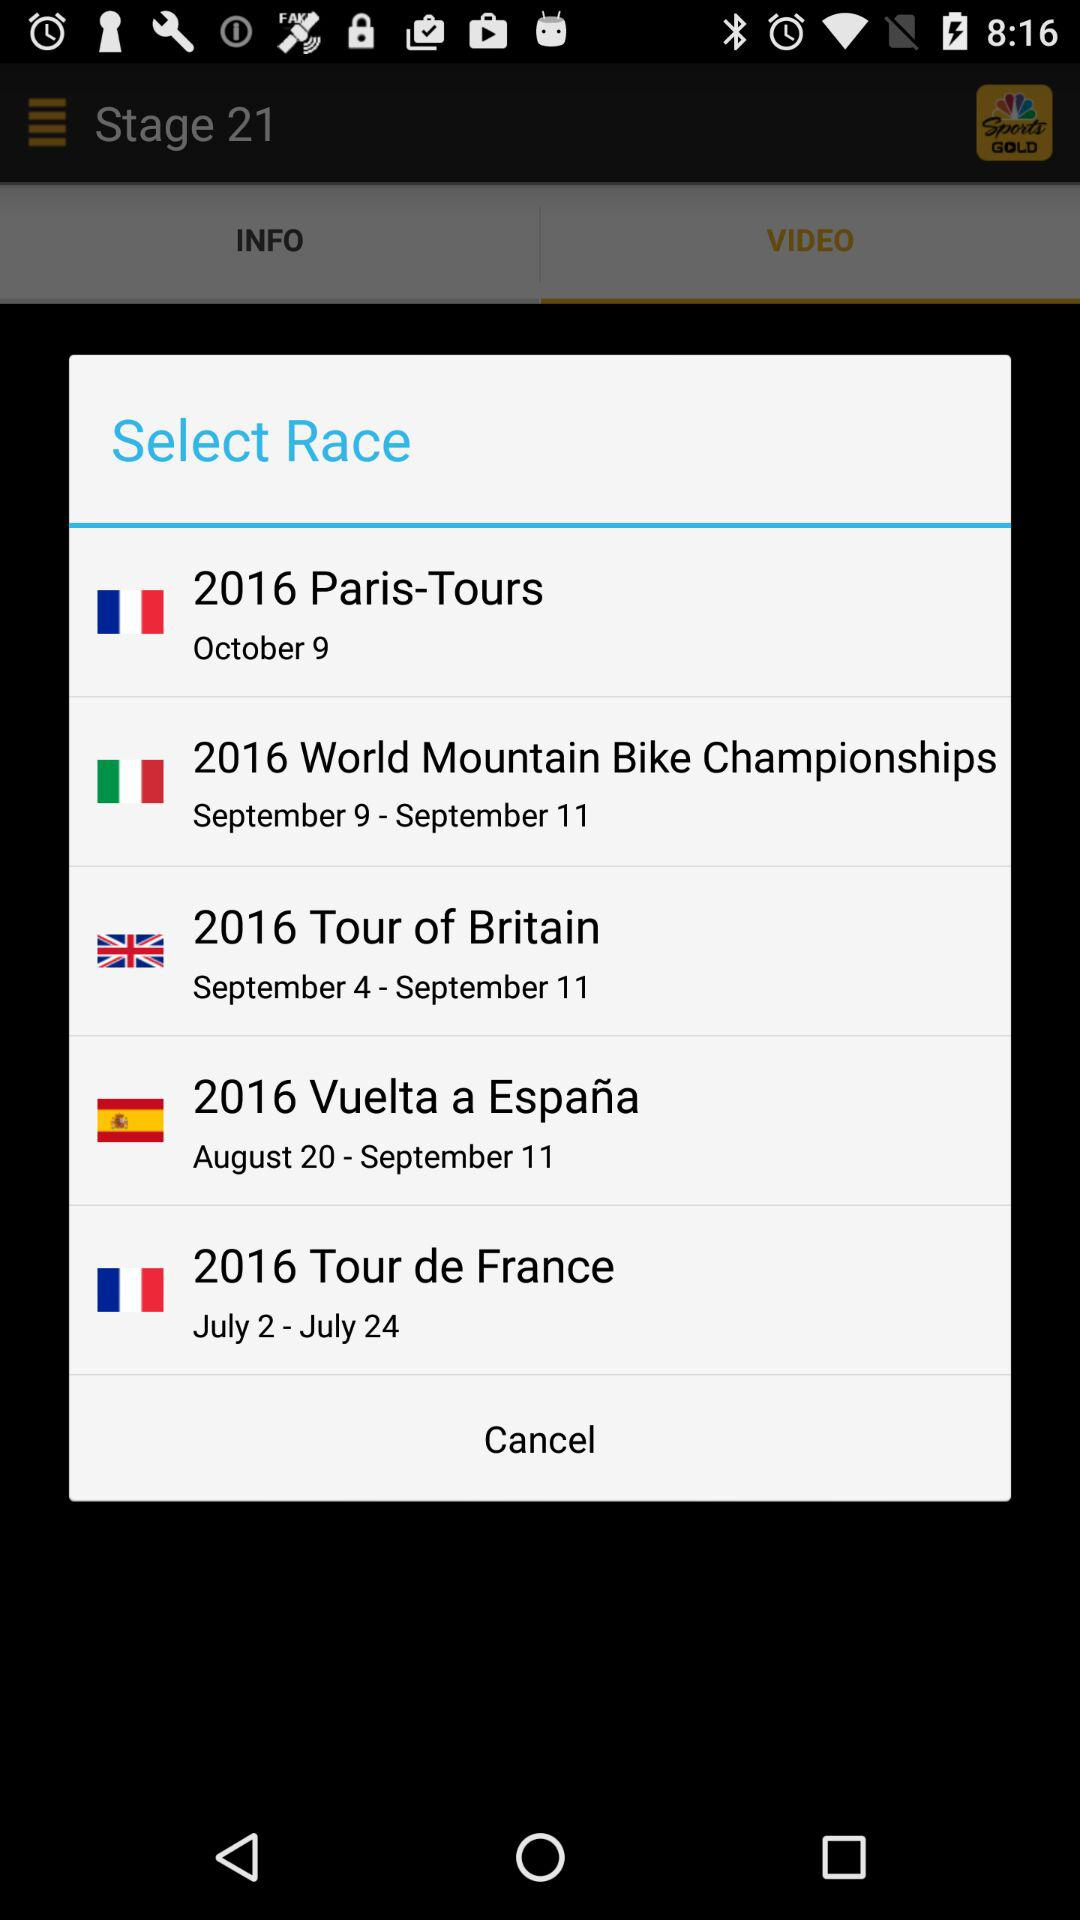What is the duration of the "2016 Tour de France"? The duration of the "2016 Tour de France" is from July 2 to July 24. 